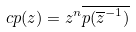Convert formula to latex. <formula><loc_0><loc_0><loc_500><loc_500>c p ( z ) = z ^ { n } \overline { p ( \overline { z } ^ { - 1 } ) }</formula> 